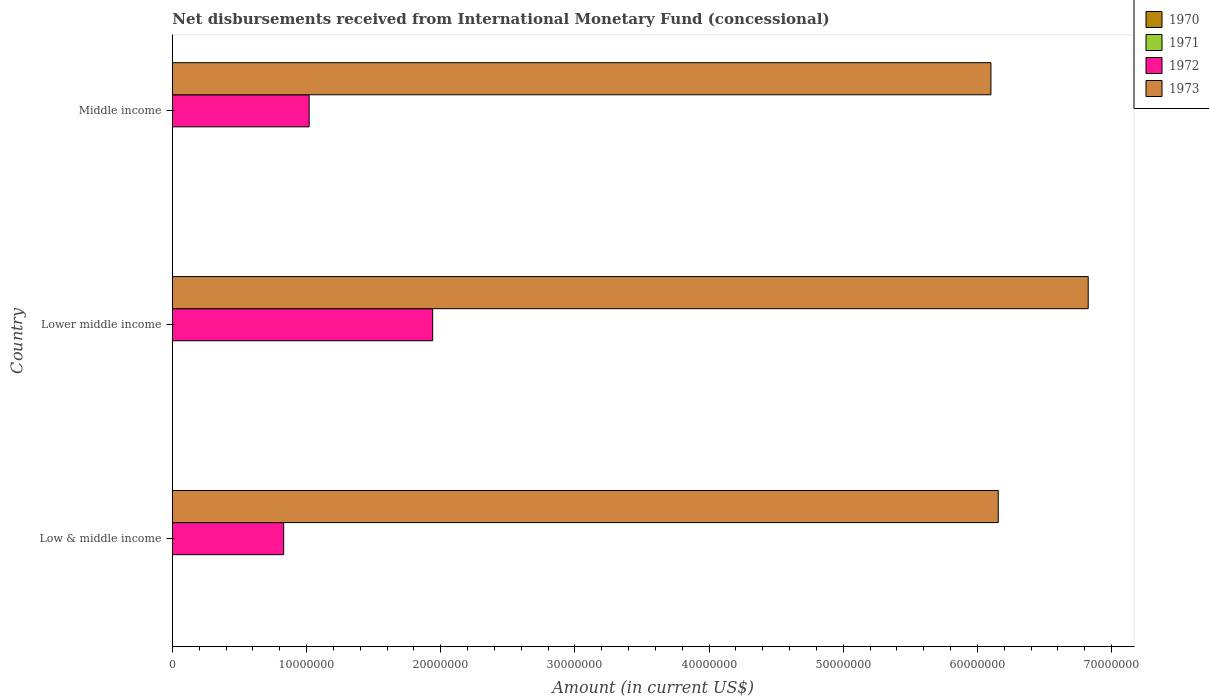How many different coloured bars are there?
Your response must be concise. 2. Are the number of bars per tick equal to the number of legend labels?
Keep it short and to the point. No. Are the number of bars on each tick of the Y-axis equal?
Keep it short and to the point. Yes. How many bars are there on the 3rd tick from the bottom?
Your answer should be very brief. 2. What is the amount of disbursements received from International Monetary Fund in 1972 in Middle income?
Make the answer very short. 1.02e+07. Across all countries, what is the maximum amount of disbursements received from International Monetary Fund in 1973?
Give a very brief answer. 6.83e+07. Across all countries, what is the minimum amount of disbursements received from International Monetary Fund in 1972?
Offer a very short reply. 8.30e+06. What is the total amount of disbursements received from International Monetary Fund in 1971 in the graph?
Provide a short and direct response. 0. What is the difference between the amount of disbursements received from International Monetary Fund in 1972 in Low & middle income and that in Lower middle income?
Your answer should be compact. -1.11e+07. What is the difference between the amount of disbursements received from International Monetary Fund in 1971 in Lower middle income and the amount of disbursements received from International Monetary Fund in 1972 in Middle income?
Your answer should be compact. -1.02e+07. What is the difference between the amount of disbursements received from International Monetary Fund in 1972 and amount of disbursements received from International Monetary Fund in 1973 in Middle income?
Provide a succinct answer. -5.08e+07. What is the ratio of the amount of disbursements received from International Monetary Fund in 1972 in Lower middle income to that in Middle income?
Provide a succinct answer. 1.9. Is the amount of disbursements received from International Monetary Fund in 1973 in Low & middle income less than that in Middle income?
Offer a terse response. No. Is the difference between the amount of disbursements received from International Monetary Fund in 1972 in Lower middle income and Middle income greater than the difference between the amount of disbursements received from International Monetary Fund in 1973 in Lower middle income and Middle income?
Give a very brief answer. Yes. What is the difference between the highest and the second highest amount of disbursements received from International Monetary Fund in 1973?
Offer a terse response. 6.70e+06. What is the difference between the highest and the lowest amount of disbursements received from International Monetary Fund in 1972?
Your answer should be very brief. 1.11e+07. In how many countries, is the amount of disbursements received from International Monetary Fund in 1970 greater than the average amount of disbursements received from International Monetary Fund in 1970 taken over all countries?
Provide a short and direct response. 0. Is the sum of the amount of disbursements received from International Monetary Fund in 1972 in Low & middle income and Middle income greater than the maximum amount of disbursements received from International Monetary Fund in 1973 across all countries?
Ensure brevity in your answer.  No. Is it the case that in every country, the sum of the amount of disbursements received from International Monetary Fund in 1970 and amount of disbursements received from International Monetary Fund in 1972 is greater than the sum of amount of disbursements received from International Monetary Fund in 1973 and amount of disbursements received from International Monetary Fund in 1971?
Keep it short and to the point. No. Are the values on the major ticks of X-axis written in scientific E-notation?
Ensure brevity in your answer.  No. Does the graph contain any zero values?
Offer a very short reply. Yes. How many legend labels are there?
Offer a terse response. 4. What is the title of the graph?
Your answer should be compact. Net disbursements received from International Monetary Fund (concessional). What is the label or title of the Y-axis?
Your answer should be compact. Country. What is the Amount (in current US$) of 1970 in Low & middle income?
Offer a terse response. 0. What is the Amount (in current US$) in 1972 in Low & middle income?
Provide a succinct answer. 8.30e+06. What is the Amount (in current US$) of 1973 in Low & middle income?
Your answer should be compact. 6.16e+07. What is the Amount (in current US$) in 1972 in Lower middle income?
Offer a very short reply. 1.94e+07. What is the Amount (in current US$) in 1973 in Lower middle income?
Provide a short and direct response. 6.83e+07. What is the Amount (in current US$) of 1971 in Middle income?
Ensure brevity in your answer.  0. What is the Amount (in current US$) of 1972 in Middle income?
Your response must be concise. 1.02e+07. What is the Amount (in current US$) of 1973 in Middle income?
Keep it short and to the point. 6.10e+07. Across all countries, what is the maximum Amount (in current US$) in 1972?
Your response must be concise. 1.94e+07. Across all countries, what is the maximum Amount (in current US$) in 1973?
Give a very brief answer. 6.83e+07. Across all countries, what is the minimum Amount (in current US$) of 1972?
Give a very brief answer. 8.30e+06. Across all countries, what is the minimum Amount (in current US$) of 1973?
Make the answer very short. 6.10e+07. What is the total Amount (in current US$) in 1970 in the graph?
Give a very brief answer. 0. What is the total Amount (in current US$) in 1971 in the graph?
Offer a terse response. 0. What is the total Amount (in current US$) of 1972 in the graph?
Keep it short and to the point. 3.79e+07. What is the total Amount (in current US$) in 1973 in the graph?
Ensure brevity in your answer.  1.91e+08. What is the difference between the Amount (in current US$) of 1972 in Low & middle income and that in Lower middle income?
Your answer should be compact. -1.11e+07. What is the difference between the Amount (in current US$) of 1973 in Low & middle income and that in Lower middle income?
Give a very brief answer. -6.70e+06. What is the difference between the Amount (in current US$) in 1972 in Low & middle income and that in Middle income?
Provide a succinct answer. -1.90e+06. What is the difference between the Amount (in current US$) of 1973 in Low & middle income and that in Middle income?
Offer a very short reply. 5.46e+05. What is the difference between the Amount (in current US$) in 1972 in Lower middle income and that in Middle income?
Ensure brevity in your answer.  9.21e+06. What is the difference between the Amount (in current US$) in 1973 in Lower middle income and that in Middle income?
Offer a very short reply. 7.25e+06. What is the difference between the Amount (in current US$) in 1972 in Low & middle income and the Amount (in current US$) in 1973 in Lower middle income?
Offer a terse response. -6.00e+07. What is the difference between the Amount (in current US$) in 1972 in Low & middle income and the Amount (in current US$) in 1973 in Middle income?
Your response must be concise. -5.27e+07. What is the difference between the Amount (in current US$) of 1972 in Lower middle income and the Amount (in current US$) of 1973 in Middle income?
Offer a very short reply. -4.16e+07. What is the average Amount (in current US$) of 1970 per country?
Give a very brief answer. 0. What is the average Amount (in current US$) of 1972 per country?
Give a very brief answer. 1.26e+07. What is the average Amount (in current US$) in 1973 per country?
Keep it short and to the point. 6.36e+07. What is the difference between the Amount (in current US$) of 1972 and Amount (in current US$) of 1973 in Low & middle income?
Give a very brief answer. -5.33e+07. What is the difference between the Amount (in current US$) of 1972 and Amount (in current US$) of 1973 in Lower middle income?
Offer a very short reply. -4.89e+07. What is the difference between the Amount (in current US$) in 1972 and Amount (in current US$) in 1973 in Middle income?
Ensure brevity in your answer.  -5.08e+07. What is the ratio of the Amount (in current US$) of 1972 in Low & middle income to that in Lower middle income?
Your response must be concise. 0.43. What is the ratio of the Amount (in current US$) of 1973 in Low & middle income to that in Lower middle income?
Make the answer very short. 0.9. What is the ratio of the Amount (in current US$) of 1972 in Low & middle income to that in Middle income?
Provide a succinct answer. 0.81. What is the ratio of the Amount (in current US$) in 1972 in Lower middle income to that in Middle income?
Your answer should be very brief. 1.9. What is the ratio of the Amount (in current US$) in 1973 in Lower middle income to that in Middle income?
Ensure brevity in your answer.  1.12. What is the difference between the highest and the second highest Amount (in current US$) of 1972?
Offer a terse response. 9.21e+06. What is the difference between the highest and the second highest Amount (in current US$) of 1973?
Provide a succinct answer. 6.70e+06. What is the difference between the highest and the lowest Amount (in current US$) of 1972?
Provide a short and direct response. 1.11e+07. What is the difference between the highest and the lowest Amount (in current US$) in 1973?
Keep it short and to the point. 7.25e+06. 